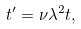Convert formula to latex. <formula><loc_0><loc_0><loc_500><loc_500>t ^ { \prime } = \nu \lambda ^ { 2 } t ,</formula> 